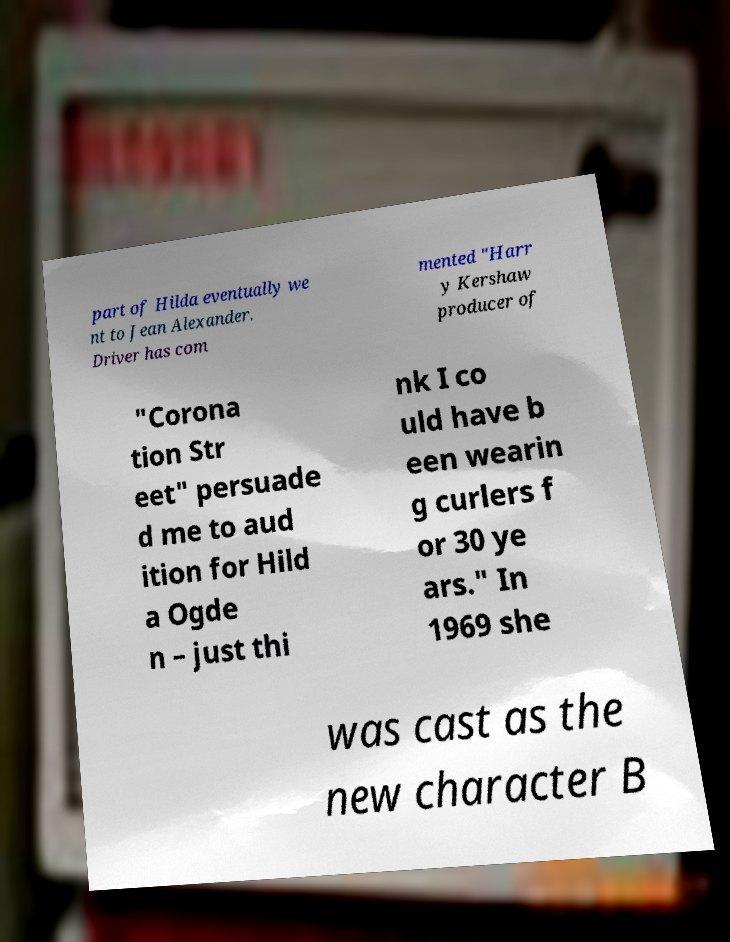Please read and relay the text visible in this image. What does it say? part of Hilda eventually we nt to Jean Alexander. Driver has com mented "Harr y Kershaw producer of "Corona tion Str eet" persuade d me to aud ition for Hild a Ogde n – just thi nk I co uld have b een wearin g curlers f or 30 ye ars." In 1969 she was cast as the new character B 